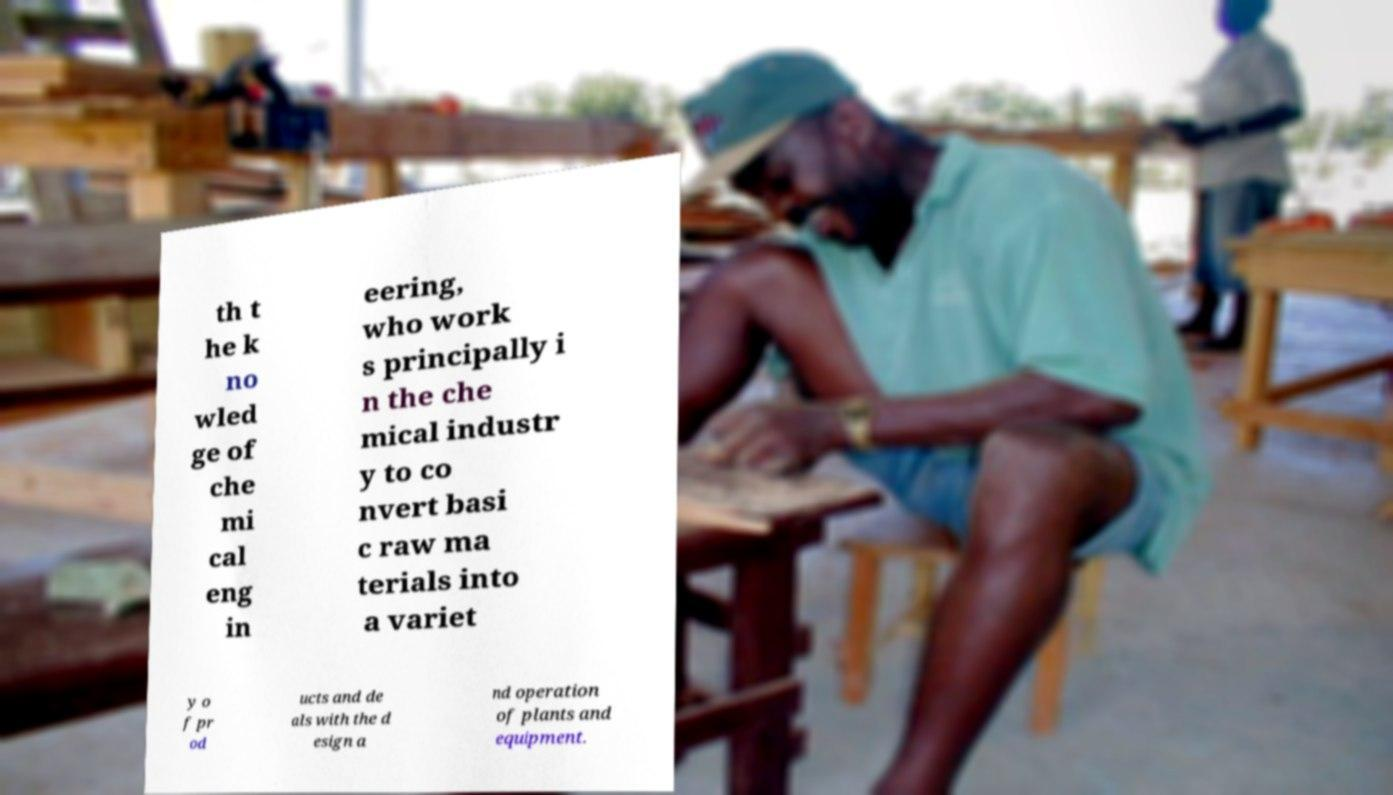Can you accurately transcribe the text from the provided image for me? th t he k no wled ge of che mi cal eng in eering, who work s principally i n the che mical industr y to co nvert basi c raw ma terials into a variet y o f pr od ucts and de als with the d esign a nd operation of plants and equipment. 